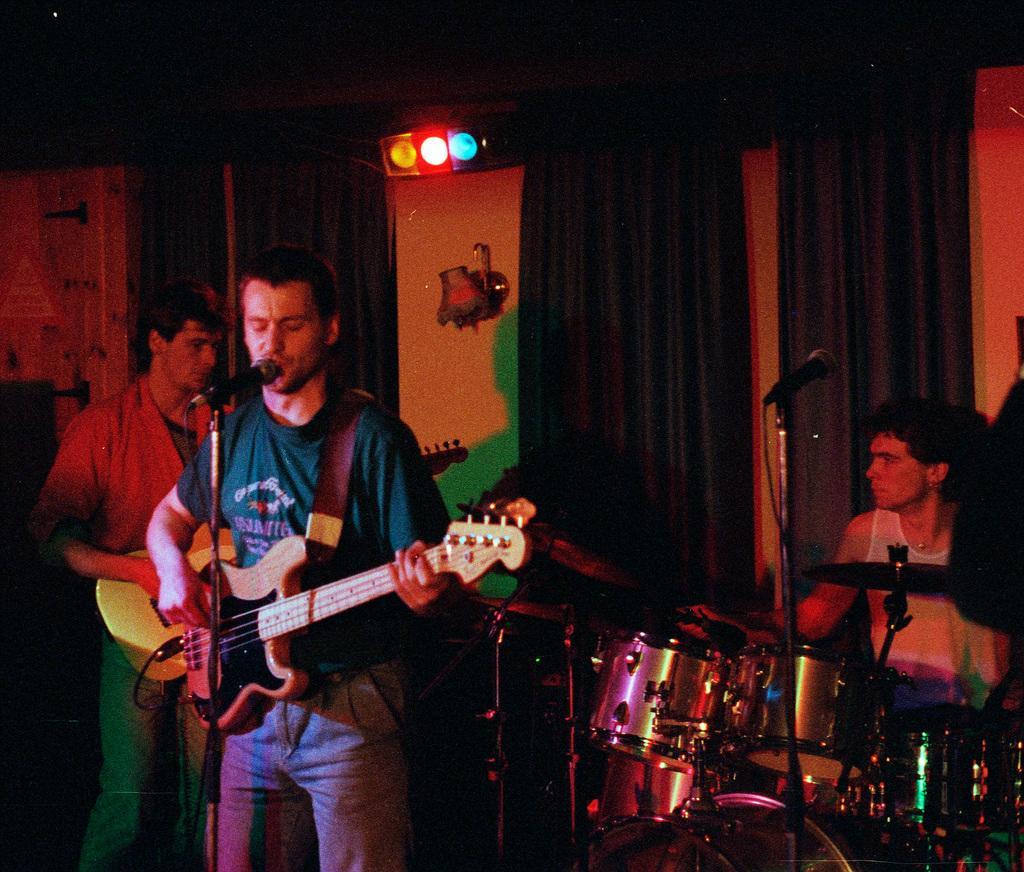How would you summarize this image in a sentence or two? This image is clicked in a musical concert. There are three people in this image, one is playing guitar and singing something, other one is playing guitar. The one who is on the right side is playing drums. There are lights on the top. There is a curtain behind them. 